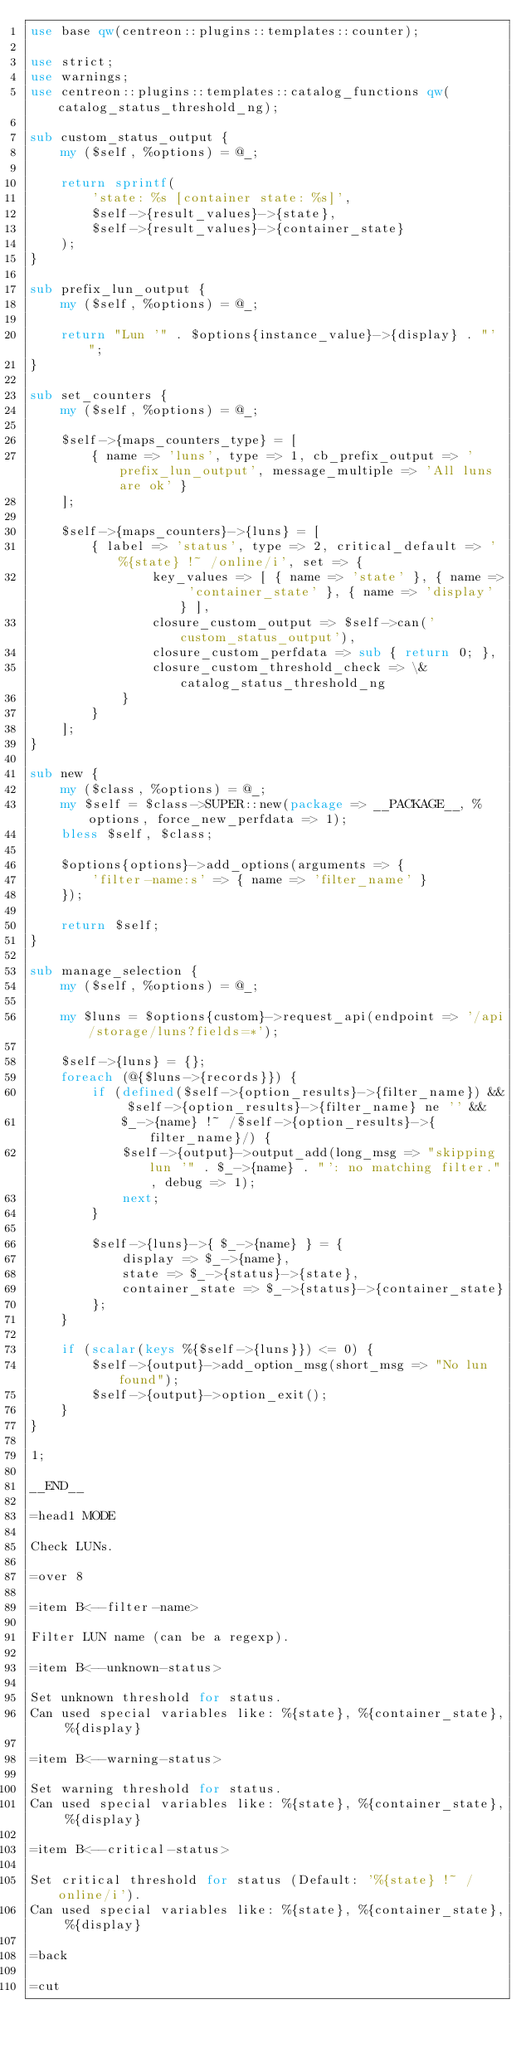<code> <loc_0><loc_0><loc_500><loc_500><_Perl_>use base qw(centreon::plugins::templates::counter);

use strict;
use warnings;
use centreon::plugins::templates::catalog_functions qw(catalog_status_threshold_ng);

sub custom_status_output {
    my ($self, %options) = @_;

    return sprintf(
        'state: %s [container state: %s]',
        $self->{result_values}->{state},
        $self->{result_values}->{container_state}
    );
}

sub prefix_lun_output {
    my ($self, %options) = @_;

    return "Lun '" . $options{instance_value}->{display} . "' ";
}

sub set_counters {
    my ($self, %options) = @_;
    
    $self->{maps_counters_type} = [
        { name => 'luns', type => 1, cb_prefix_output => 'prefix_lun_output', message_multiple => 'All luns are ok' }
    ];
    
    $self->{maps_counters}->{luns} = [
        { label => 'status', type => 2, critical_default => '%{state} !~ /online/i', set => {
                key_values => [ { name => 'state' }, { name => 'container_state' }, { name => 'display' } ],
                closure_custom_output => $self->can('custom_status_output'),
                closure_custom_perfdata => sub { return 0; },
                closure_custom_threshold_check => \&catalog_status_threshold_ng
            }
        }
    ];
}

sub new {
    my ($class, %options) = @_;
    my $self = $class->SUPER::new(package => __PACKAGE__, %options, force_new_perfdata => 1);
    bless $self, $class;
    
    $options{options}->add_options(arguments => { 
        'filter-name:s' => { name => 'filter_name' }
    });
    
    return $self;
}

sub manage_selection {
    my ($self, %options) = @_;

    my $luns = $options{custom}->request_api(endpoint => '/api/storage/luns?fields=*');

    $self->{luns} = {};
    foreach (@{$luns->{records}}) {
        if (defined($self->{option_results}->{filter_name}) && $self->{option_results}->{filter_name} ne '' &&
            $_->{name} !~ /$self->{option_results}->{filter_name}/) {
            $self->{output}->output_add(long_msg => "skipping lun '" . $_->{name} . "': no matching filter.", debug => 1);
            next;
        }

        $self->{luns}->{ $_->{name} } = {
            display => $_->{name},
            state => $_->{status}->{state},
            container_state => $_->{status}->{container_state}
        };
    }
    
    if (scalar(keys %{$self->{luns}}) <= 0) {
        $self->{output}->add_option_msg(short_msg => "No lun found");
        $self->{output}->option_exit();
    }
}

1;

__END__

=head1 MODE

Check LUNs.

=over 8

=item B<--filter-name>

Filter LUN name (can be a regexp).

=item B<--unknown-status>

Set unknown threshold for status.
Can used special variables like: %{state}, %{container_state}, %{display}

=item B<--warning-status>

Set warning threshold for status.
Can used special variables like: %{state}, %{container_state}, %{display}

=item B<--critical-status>

Set critical threshold for status (Default: '%{state} !~ /online/i').
Can used special variables like: %{state}, %{container_state}, %{display}

=back

=cut
</code> 